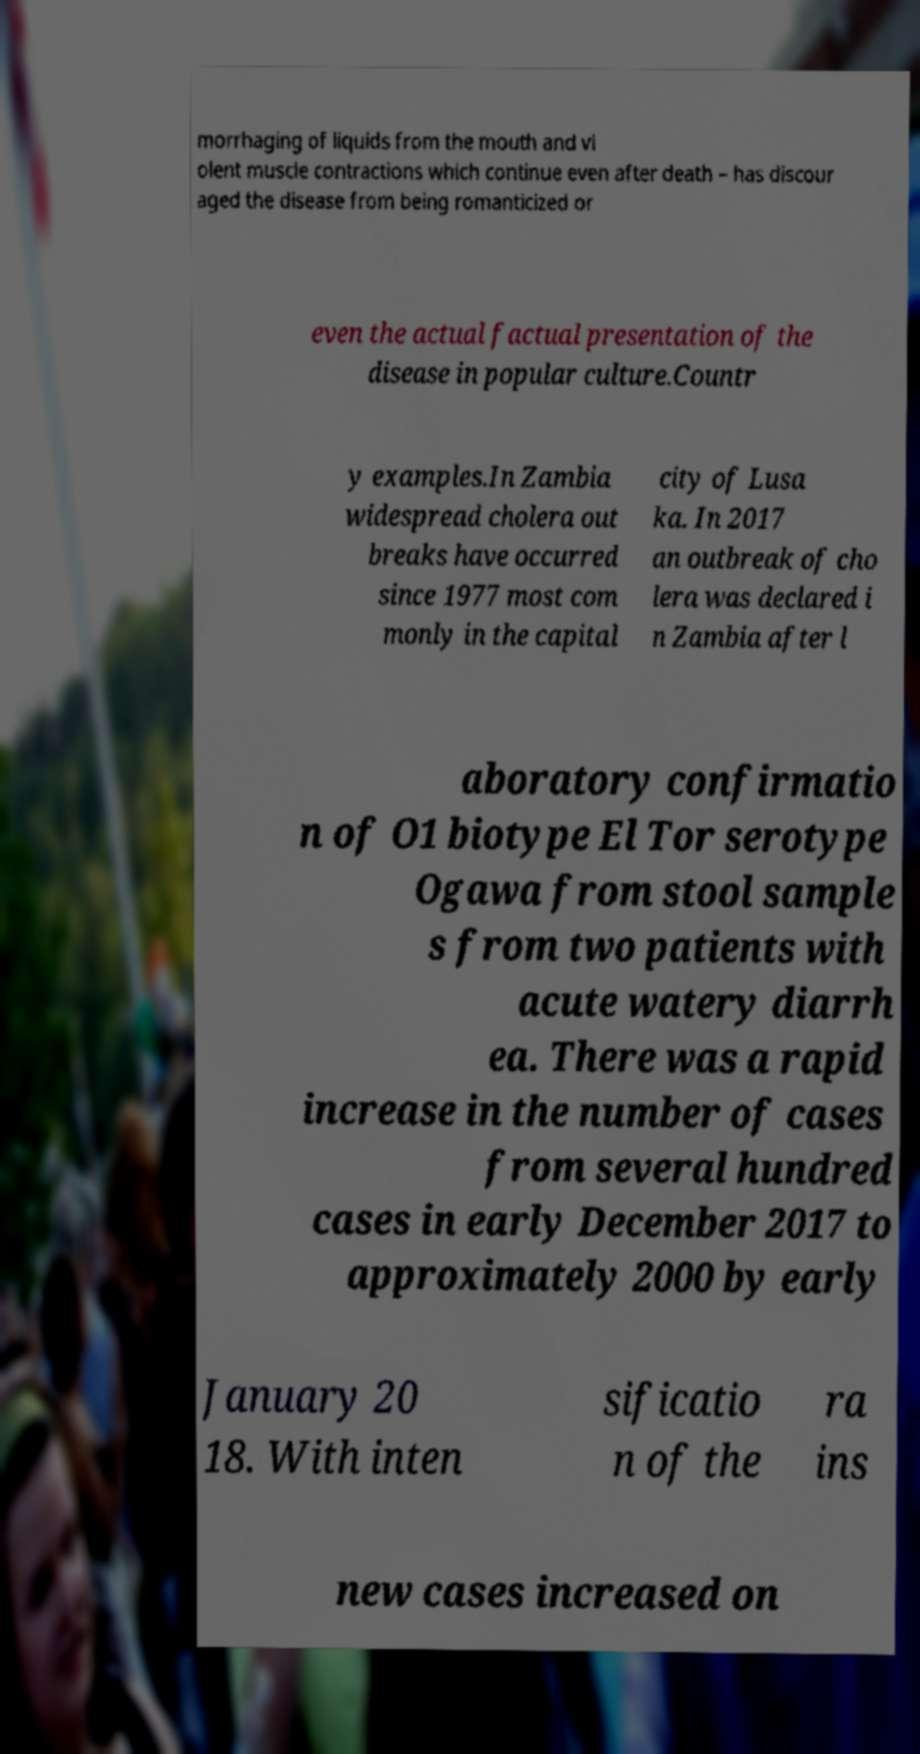What messages or text are displayed in this image? I need them in a readable, typed format. morrhaging of liquids from the mouth and vi olent muscle contractions which continue even after death – has discour aged the disease from being romanticized or even the actual factual presentation of the disease in popular culture.Countr y examples.In Zambia widespread cholera out breaks have occurred since 1977 most com monly in the capital city of Lusa ka. In 2017 an outbreak of cho lera was declared i n Zambia after l aboratory confirmatio n of O1 biotype El Tor serotype Ogawa from stool sample s from two patients with acute watery diarrh ea. There was a rapid increase in the number of cases from several hundred cases in early December 2017 to approximately 2000 by early January 20 18. With inten sificatio n of the ra ins new cases increased on 